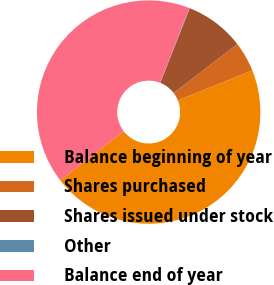Convert chart to OTSL. <chart><loc_0><loc_0><loc_500><loc_500><pie_chart><fcel>Balance beginning of year<fcel>Shares purchased<fcel>Shares issued under stock<fcel>Other<fcel>Balance end of year<nl><fcel>45.64%<fcel>4.33%<fcel>8.58%<fcel>0.07%<fcel>41.38%<nl></chart> 